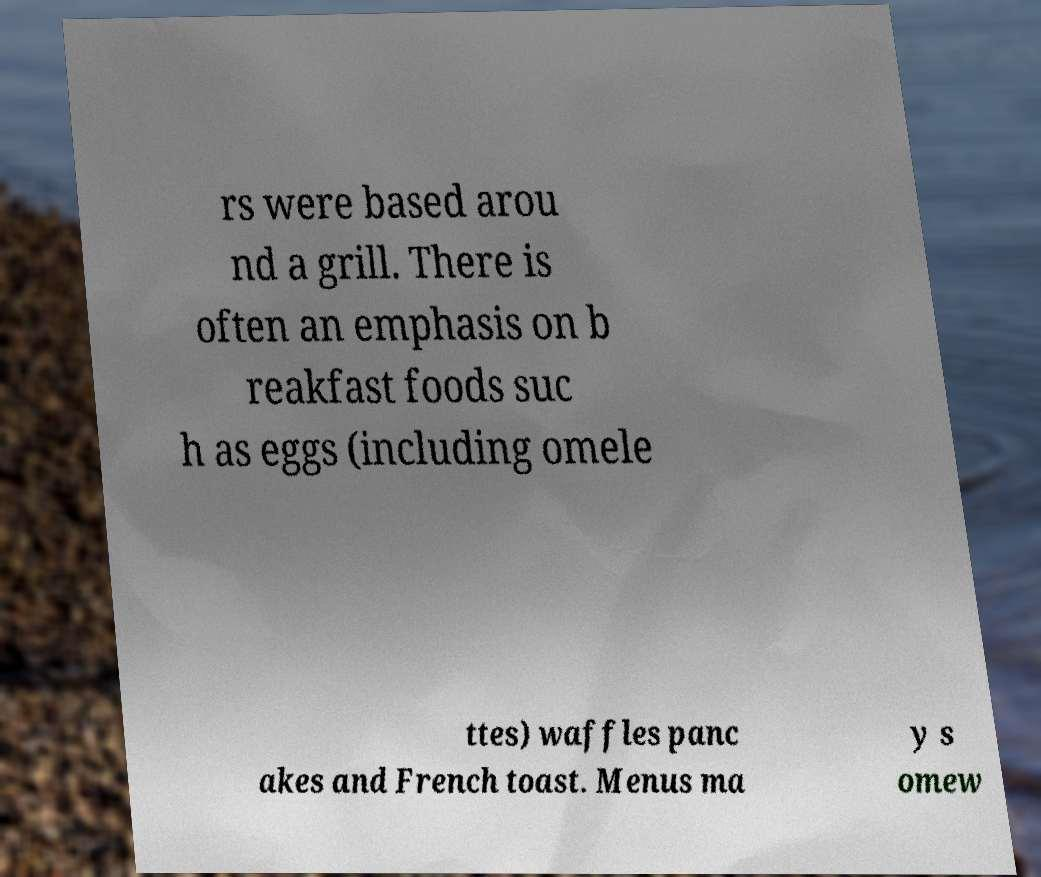Could you assist in decoding the text presented in this image and type it out clearly? rs were based arou nd a grill. There is often an emphasis on b reakfast foods suc h as eggs (including omele ttes) waffles panc akes and French toast. Menus ma y s omew 